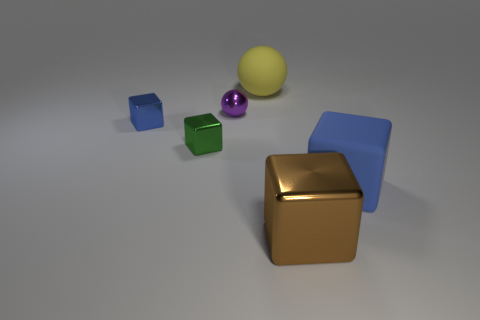If I were to organize these objects by size, how would you suggest I categorize them? You could categorize them as follows: the gold cube being the largest; the blue and green cubes are medium-sized and seem to be of equal size; the purple and yellow spheres are the smallest objects in the image. 